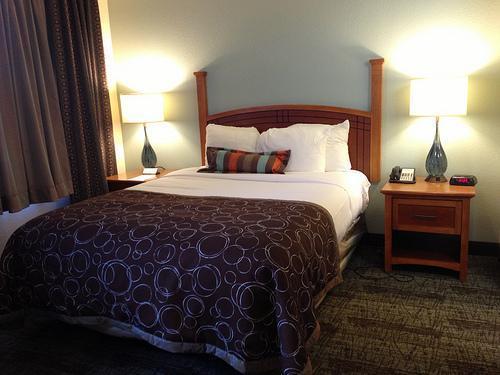How many lamps are there?
Give a very brief answer. 2. How many clocks are there?
Give a very brief answer. 1. 